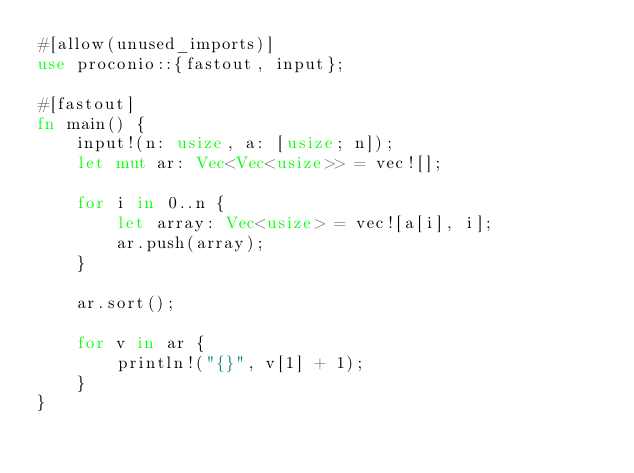<code> <loc_0><loc_0><loc_500><loc_500><_Rust_>#[allow(unused_imports)]
use proconio::{fastout, input};

#[fastout]
fn main() {
    input!(n: usize, a: [usize; n]);
    let mut ar: Vec<Vec<usize>> = vec![];

    for i in 0..n {
        let array: Vec<usize> = vec![a[i], i];
        ar.push(array);
    }

    ar.sort();

    for v in ar {
        println!("{}", v[1] + 1);
    }
}
</code> 